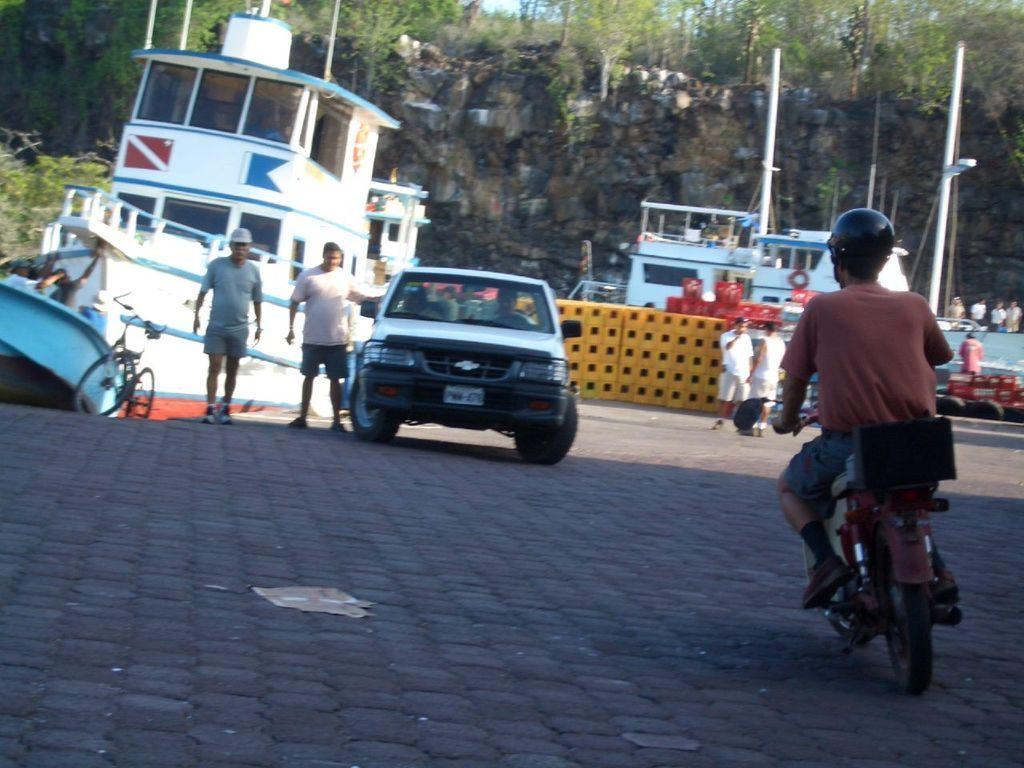What is the main subject in the middle of the image? There is a car in the middle of the image. What is the man on the right side of the image doing? The man is riding a motorbike on the right side of the image. How many men are standing on the left side of the image? There are two men standing on the left side of the image. What can be seen in the background of the image? There is a boat and trees in the background of the image, along with people. What is the name of the scarecrow in the image? There is no scarecrow present in the image. Can you tell me how many bats are flying around the car in the image? There are no bats present in the image. 